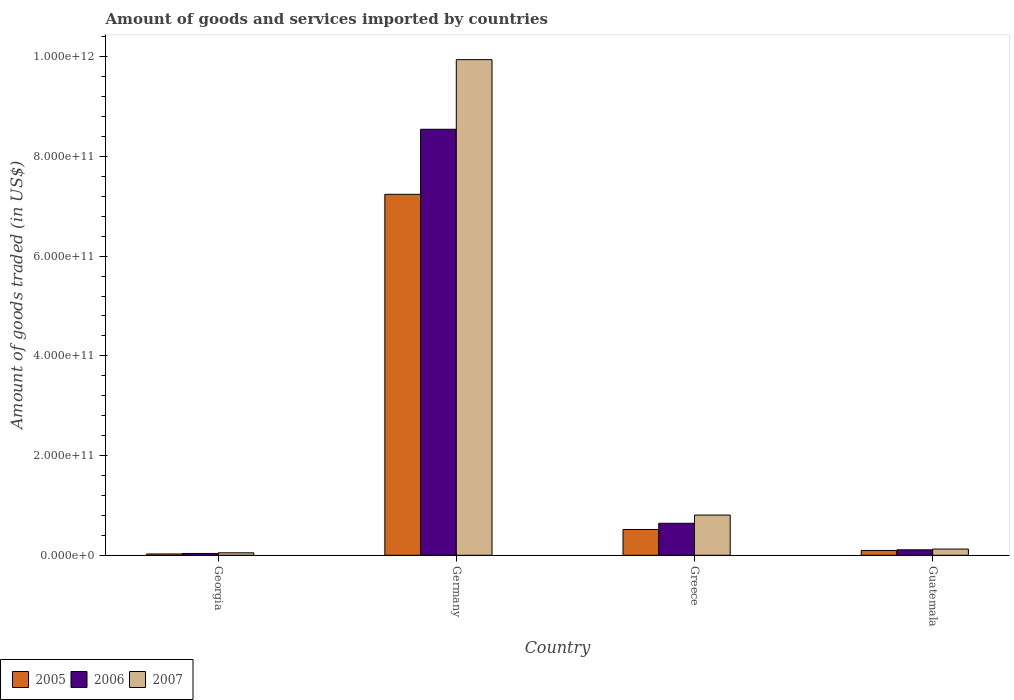How many different coloured bars are there?
Offer a very short reply. 3. Are the number of bars on each tick of the X-axis equal?
Provide a succinct answer. Yes. What is the label of the 1st group of bars from the left?
Your response must be concise. Georgia. What is the total amount of goods and services imported in 2005 in Greece?
Give a very brief answer. 5.17e+1. Across all countries, what is the maximum total amount of goods and services imported in 2005?
Your answer should be very brief. 7.24e+11. Across all countries, what is the minimum total amount of goods and services imported in 2007?
Provide a short and direct response. 4.94e+09. In which country was the total amount of goods and services imported in 2006 maximum?
Keep it short and to the point. Germany. In which country was the total amount of goods and services imported in 2007 minimum?
Offer a very short reply. Georgia. What is the total total amount of goods and services imported in 2006 in the graph?
Keep it short and to the point. 9.33e+11. What is the difference between the total amount of goods and services imported in 2005 in Germany and that in Greece?
Give a very brief answer. 6.72e+11. What is the difference between the total amount of goods and services imported in 2006 in Georgia and the total amount of goods and services imported in 2005 in Guatemala?
Your answer should be very brief. -6.01e+09. What is the average total amount of goods and services imported in 2005 per country?
Ensure brevity in your answer.  1.97e+11. What is the difference between the total amount of goods and services imported of/in 2005 and total amount of goods and services imported of/in 2007 in Guatemala?
Provide a short and direct response. -2.82e+09. In how many countries, is the total amount of goods and services imported in 2006 greater than 320000000000 US$?
Your answer should be very brief. 1. What is the ratio of the total amount of goods and services imported in 2007 in Greece to that in Guatemala?
Your response must be concise. 6.47. Is the total amount of goods and services imported in 2007 in Georgia less than that in Guatemala?
Your answer should be very brief. Yes. What is the difference between the highest and the second highest total amount of goods and services imported in 2007?
Provide a short and direct response. 9.13e+11. What is the difference between the highest and the lowest total amount of goods and services imported in 2007?
Your response must be concise. 9.89e+11. What does the 1st bar from the left in Germany represents?
Provide a succinct answer. 2005. What does the 1st bar from the right in Greece represents?
Your response must be concise. 2007. How many bars are there?
Give a very brief answer. 12. Are all the bars in the graph horizontal?
Make the answer very short. No. What is the difference between two consecutive major ticks on the Y-axis?
Give a very brief answer. 2.00e+11. Are the values on the major ticks of Y-axis written in scientific E-notation?
Provide a succinct answer. Yes. How are the legend labels stacked?
Your answer should be compact. Horizontal. What is the title of the graph?
Your answer should be very brief. Amount of goods and services imported by countries. What is the label or title of the Y-axis?
Provide a short and direct response. Amount of goods traded (in US$). What is the Amount of goods traded (in US$) in 2005 in Georgia?
Offer a very short reply. 2.63e+09. What is the Amount of goods traded (in US$) of 2006 in Georgia?
Your response must be concise. 3.64e+09. What is the Amount of goods traded (in US$) of 2007 in Georgia?
Your response must be concise. 4.94e+09. What is the Amount of goods traded (in US$) in 2005 in Germany?
Your answer should be compact. 7.24e+11. What is the Amount of goods traded (in US$) in 2006 in Germany?
Offer a terse response. 8.54e+11. What is the Amount of goods traded (in US$) of 2007 in Germany?
Keep it short and to the point. 9.94e+11. What is the Amount of goods traded (in US$) of 2005 in Greece?
Offer a terse response. 5.17e+1. What is the Amount of goods traded (in US$) in 2006 in Greece?
Ensure brevity in your answer.  6.42e+1. What is the Amount of goods traded (in US$) of 2007 in Greece?
Your answer should be very brief. 8.07e+1. What is the Amount of goods traded (in US$) in 2005 in Guatemala?
Make the answer very short. 9.65e+09. What is the Amount of goods traded (in US$) in 2006 in Guatemala?
Your answer should be very brief. 1.09e+1. What is the Amount of goods traded (in US$) of 2007 in Guatemala?
Make the answer very short. 1.25e+1. Across all countries, what is the maximum Amount of goods traded (in US$) of 2005?
Make the answer very short. 7.24e+11. Across all countries, what is the maximum Amount of goods traded (in US$) in 2006?
Provide a succinct answer. 8.54e+11. Across all countries, what is the maximum Amount of goods traded (in US$) in 2007?
Ensure brevity in your answer.  9.94e+11. Across all countries, what is the minimum Amount of goods traded (in US$) of 2005?
Ensure brevity in your answer.  2.63e+09. Across all countries, what is the minimum Amount of goods traded (in US$) in 2006?
Keep it short and to the point. 3.64e+09. Across all countries, what is the minimum Amount of goods traded (in US$) in 2007?
Provide a short and direct response. 4.94e+09. What is the total Amount of goods traded (in US$) of 2005 in the graph?
Ensure brevity in your answer.  7.88e+11. What is the total Amount of goods traded (in US$) in 2006 in the graph?
Offer a terse response. 9.33e+11. What is the total Amount of goods traded (in US$) of 2007 in the graph?
Your answer should be compact. 1.09e+12. What is the difference between the Amount of goods traded (in US$) in 2005 in Georgia and that in Germany?
Your answer should be very brief. -7.21e+11. What is the difference between the Amount of goods traded (in US$) in 2006 in Georgia and that in Germany?
Provide a succinct answer. -8.51e+11. What is the difference between the Amount of goods traded (in US$) in 2007 in Georgia and that in Germany?
Make the answer very short. -9.89e+11. What is the difference between the Amount of goods traded (in US$) of 2005 in Georgia and that in Greece?
Provide a succinct answer. -4.91e+1. What is the difference between the Amount of goods traded (in US$) in 2006 in Georgia and that in Greece?
Offer a very short reply. -6.05e+1. What is the difference between the Amount of goods traded (in US$) of 2007 in Georgia and that in Greece?
Your response must be concise. -7.57e+1. What is the difference between the Amount of goods traded (in US$) in 2005 in Georgia and that in Guatemala?
Offer a terse response. -7.02e+09. What is the difference between the Amount of goods traded (in US$) in 2006 in Georgia and that in Guatemala?
Your answer should be compact. -7.29e+09. What is the difference between the Amount of goods traded (in US$) in 2007 in Georgia and that in Guatemala?
Your answer should be very brief. -7.53e+09. What is the difference between the Amount of goods traded (in US$) in 2005 in Germany and that in Greece?
Your answer should be compact. 6.72e+11. What is the difference between the Amount of goods traded (in US$) of 2006 in Germany and that in Greece?
Ensure brevity in your answer.  7.90e+11. What is the difference between the Amount of goods traded (in US$) in 2007 in Germany and that in Greece?
Your answer should be very brief. 9.13e+11. What is the difference between the Amount of goods traded (in US$) of 2005 in Germany and that in Guatemala?
Your response must be concise. 7.14e+11. What is the difference between the Amount of goods traded (in US$) of 2006 in Germany and that in Guatemala?
Provide a succinct answer. 8.44e+11. What is the difference between the Amount of goods traded (in US$) in 2007 in Germany and that in Guatemala?
Your response must be concise. 9.82e+11. What is the difference between the Amount of goods traded (in US$) of 2005 in Greece and that in Guatemala?
Give a very brief answer. 4.21e+1. What is the difference between the Amount of goods traded (in US$) of 2006 in Greece and that in Guatemala?
Ensure brevity in your answer.  5.32e+1. What is the difference between the Amount of goods traded (in US$) of 2007 in Greece and that in Guatemala?
Your answer should be very brief. 6.82e+1. What is the difference between the Amount of goods traded (in US$) of 2005 in Georgia and the Amount of goods traded (in US$) of 2006 in Germany?
Provide a succinct answer. -8.52e+11. What is the difference between the Amount of goods traded (in US$) in 2005 in Georgia and the Amount of goods traded (in US$) in 2007 in Germany?
Keep it short and to the point. -9.91e+11. What is the difference between the Amount of goods traded (in US$) of 2006 in Georgia and the Amount of goods traded (in US$) of 2007 in Germany?
Provide a short and direct response. -9.90e+11. What is the difference between the Amount of goods traded (in US$) of 2005 in Georgia and the Amount of goods traded (in US$) of 2006 in Greece?
Give a very brief answer. -6.15e+1. What is the difference between the Amount of goods traded (in US$) of 2005 in Georgia and the Amount of goods traded (in US$) of 2007 in Greece?
Your answer should be very brief. -7.80e+1. What is the difference between the Amount of goods traded (in US$) of 2006 in Georgia and the Amount of goods traded (in US$) of 2007 in Greece?
Your response must be concise. -7.70e+1. What is the difference between the Amount of goods traded (in US$) of 2005 in Georgia and the Amount of goods traded (in US$) of 2006 in Guatemala?
Your response must be concise. -8.30e+09. What is the difference between the Amount of goods traded (in US$) of 2005 in Georgia and the Amount of goods traded (in US$) of 2007 in Guatemala?
Offer a terse response. -9.84e+09. What is the difference between the Amount of goods traded (in US$) of 2006 in Georgia and the Amount of goods traded (in US$) of 2007 in Guatemala?
Your response must be concise. -8.83e+09. What is the difference between the Amount of goods traded (in US$) of 2005 in Germany and the Amount of goods traded (in US$) of 2006 in Greece?
Offer a very short reply. 6.60e+11. What is the difference between the Amount of goods traded (in US$) in 2005 in Germany and the Amount of goods traded (in US$) in 2007 in Greece?
Offer a terse response. 6.43e+11. What is the difference between the Amount of goods traded (in US$) in 2006 in Germany and the Amount of goods traded (in US$) in 2007 in Greece?
Keep it short and to the point. 7.74e+11. What is the difference between the Amount of goods traded (in US$) of 2005 in Germany and the Amount of goods traded (in US$) of 2006 in Guatemala?
Your answer should be very brief. 7.13e+11. What is the difference between the Amount of goods traded (in US$) of 2005 in Germany and the Amount of goods traded (in US$) of 2007 in Guatemala?
Provide a short and direct response. 7.12e+11. What is the difference between the Amount of goods traded (in US$) of 2006 in Germany and the Amount of goods traded (in US$) of 2007 in Guatemala?
Ensure brevity in your answer.  8.42e+11. What is the difference between the Amount of goods traded (in US$) of 2005 in Greece and the Amount of goods traded (in US$) of 2006 in Guatemala?
Your answer should be compact. 4.08e+1. What is the difference between the Amount of goods traded (in US$) in 2005 in Greece and the Amount of goods traded (in US$) in 2007 in Guatemala?
Ensure brevity in your answer.  3.92e+1. What is the difference between the Amount of goods traded (in US$) in 2006 in Greece and the Amount of goods traded (in US$) in 2007 in Guatemala?
Your answer should be very brief. 5.17e+1. What is the average Amount of goods traded (in US$) in 2005 per country?
Give a very brief answer. 1.97e+11. What is the average Amount of goods traded (in US$) of 2006 per country?
Make the answer very short. 2.33e+11. What is the average Amount of goods traded (in US$) of 2007 per country?
Offer a very short reply. 2.73e+11. What is the difference between the Amount of goods traded (in US$) of 2005 and Amount of goods traded (in US$) of 2006 in Georgia?
Offer a very short reply. -1.01e+09. What is the difference between the Amount of goods traded (in US$) in 2005 and Amount of goods traded (in US$) in 2007 in Georgia?
Make the answer very short. -2.31e+09. What is the difference between the Amount of goods traded (in US$) of 2006 and Amount of goods traded (in US$) of 2007 in Georgia?
Ensure brevity in your answer.  -1.30e+09. What is the difference between the Amount of goods traded (in US$) in 2005 and Amount of goods traded (in US$) in 2006 in Germany?
Provide a short and direct response. -1.30e+11. What is the difference between the Amount of goods traded (in US$) in 2005 and Amount of goods traded (in US$) in 2007 in Germany?
Your answer should be very brief. -2.70e+11. What is the difference between the Amount of goods traded (in US$) of 2006 and Amount of goods traded (in US$) of 2007 in Germany?
Ensure brevity in your answer.  -1.40e+11. What is the difference between the Amount of goods traded (in US$) in 2005 and Amount of goods traded (in US$) in 2006 in Greece?
Provide a succinct answer. -1.25e+1. What is the difference between the Amount of goods traded (in US$) in 2005 and Amount of goods traded (in US$) in 2007 in Greece?
Keep it short and to the point. -2.90e+1. What is the difference between the Amount of goods traded (in US$) of 2006 and Amount of goods traded (in US$) of 2007 in Greece?
Offer a terse response. -1.65e+1. What is the difference between the Amount of goods traded (in US$) of 2005 and Amount of goods traded (in US$) of 2006 in Guatemala?
Give a very brief answer. -1.28e+09. What is the difference between the Amount of goods traded (in US$) in 2005 and Amount of goods traded (in US$) in 2007 in Guatemala?
Ensure brevity in your answer.  -2.82e+09. What is the difference between the Amount of goods traded (in US$) in 2006 and Amount of goods traded (in US$) in 2007 in Guatemala?
Keep it short and to the point. -1.54e+09. What is the ratio of the Amount of goods traded (in US$) in 2005 in Georgia to that in Germany?
Your answer should be very brief. 0. What is the ratio of the Amount of goods traded (in US$) in 2006 in Georgia to that in Germany?
Offer a very short reply. 0. What is the ratio of the Amount of goods traded (in US$) in 2007 in Georgia to that in Germany?
Provide a succinct answer. 0.01. What is the ratio of the Amount of goods traded (in US$) of 2005 in Georgia to that in Greece?
Give a very brief answer. 0.05. What is the ratio of the Amount of goods traded (in US$) of 2006 in Georgia to that in Greece?
Your response must be concise. 0.06. What is the ratio of the Amount of goods traded (in US$) of 2007 in Georgia to that in Greece?
Your answer should be compact. 0.06. What is the ratio of the Amount of goods traded (in US$) of 2005 in Georgia to that in Guatemala?
Offer a very short reply. 0.27. What is the ratio of the Amount of goods traded (in US$) in 2006 in Georgia to that in Guatemala?
Your answer should be compact. 0.33. What is the ratio of the Amount of goods traded (in US$) in 2007 in Georgia to that in Guatemala?
Your answer should be compact. 0.4. What is the ratio of the Amount of goods traded (in US$) of 2005 in Germany to that in Greece?
Offer a very short reply. 14. What is the ratio of the Amount of goods traded (in US$) in 2006 in Germany to that in Greece?
Offer a terse response. 13.32. What is the ratio of the Amount of goods traded (in US$) of 2007 in Germany to that in Greece?
Make the answer very short. 12.32. What is the ratio of the Amount of goods traded (in US$) in 2005 in Germany to that in Guatemala?
Ensure brevity in your answer.  75.02. What is the ratio of the Amount of goods traded (in US$) in 2006 in Germany to that in Guatemala?
Keep it short and to the point. 78.14. What is the ratio of the Amount of goods traded (in US$) of 2007 in Germany to that in Guatemala?
Give a very brief answer. 79.72. What is the ratio of the Amount of goods traded (in US$) of 2005 in Greece to that in Guatemala?
Provide a short and direct response. 5.36. What is the ratio of the Amount of goods traded (in US$) in 2006 in Greece to that in Guatemala?
Your response must be concise. 5.87. What is the ratio of the Amount of goods traded (in US$) of 2007 in Greece to that in Guatemala?
Offer a terse response. 6.47. What is the difference between the highest and the second highest Amount of goods traded (in US$) in 2005?
Make the answer very short. 6.72e+11. What is the difference between the highest and the second highest Amount of goods traded (in US$) in 2006?
Your answer should be very brief. 7.90e+11. What is the difference between the highest and the second highest Amount of goods traded (in US$) of 2007?
Offer a terse response. 9.13e+11. What is the difference between the highest and the lowest Amount of goods traded (in US$) of 2005?
Provide a short and direct response. 7.21e+11. What is the difference between the highest and the lowest Amount of goods traded (in US$) of 2006?
Offer a very short reply. 8.51e+11. What is the difference between the highest and the lowest Amount of goods traded (in US$) in 2007?
Your answer should be very brief. 9.89e+11. 